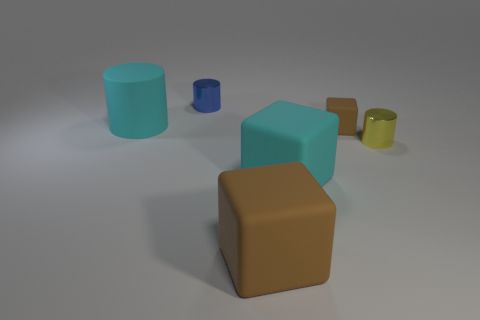Subtract all brown cubes. How many were subtracted if there are1brown cubes left? 1 Subtract all gray spheres. How many brown blocks are left? 2 Subtract all shiny cylinders. How many cylinders are left? 1 Add 3 small blue shiny objects. How many objects exist? 9 Subtract 1 cylinders. How many cylinders are left? 2 Subtract all brown cylinders. Subtract all cyan cubes. How many cylinders are left? 3 Add 6 yellow metal cylinders. How many yellow metal cylinders exist? 7 Subtract 1 blue cylinders. How many objects are left? 5 Subtract all tiny purple spheres. Subtract all small objects. How many objects are left? 3 Add 5 large rubber cylinders. How many large rubber cylinders are left? 6 